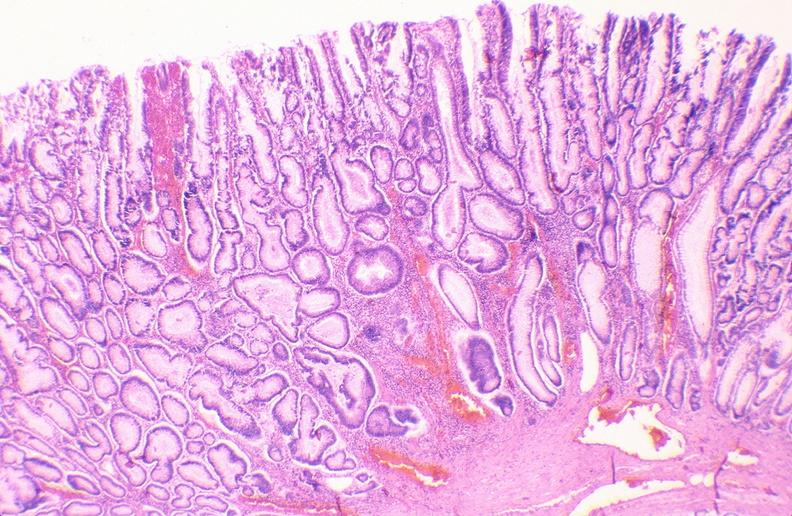what does this image show?
Answer the question using a single word or phrase. Colon 